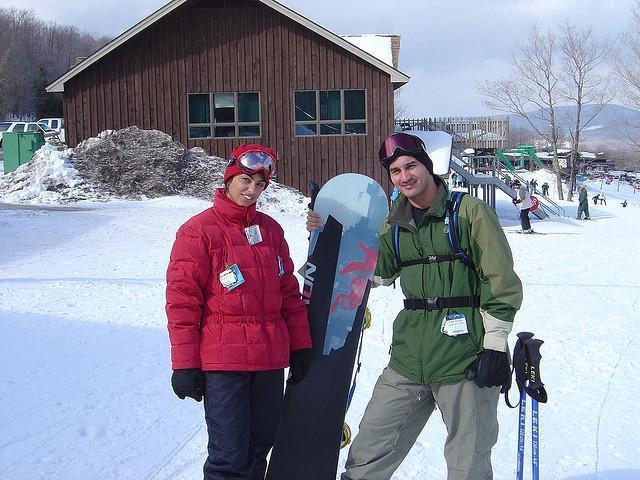How many people are there?
Give a very brief answer. 2. How many boats are in the picture?
Give a very brief answer. 0. 